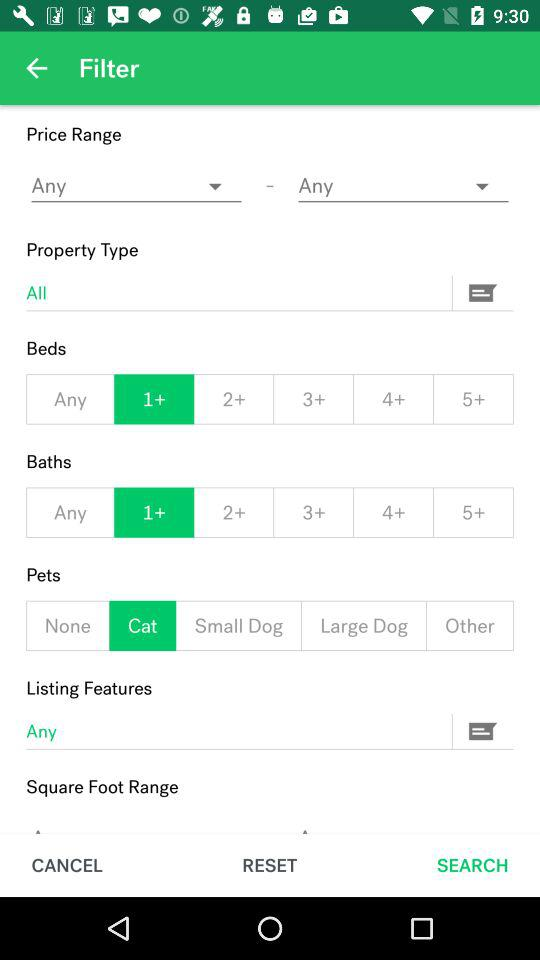Which pet is selected? The selected pet is a cat. 